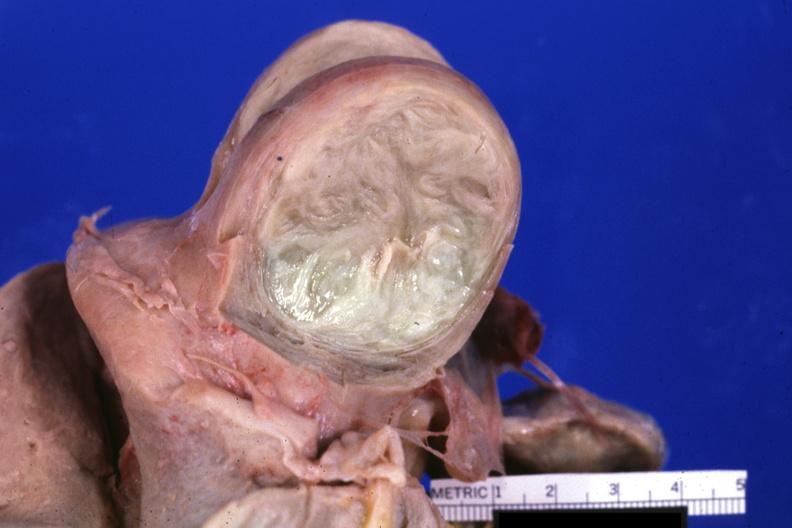s cranial artery present?
Answer the question using a single word or phrase. No 